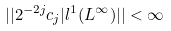<formula> <loc_0><loc_0><loc_500><loc_500>| | 2 ^ { - 2 j } c _ { j } | l ^ { 1 } ( L ^ { \infty } ) | | < \infty</formula> 